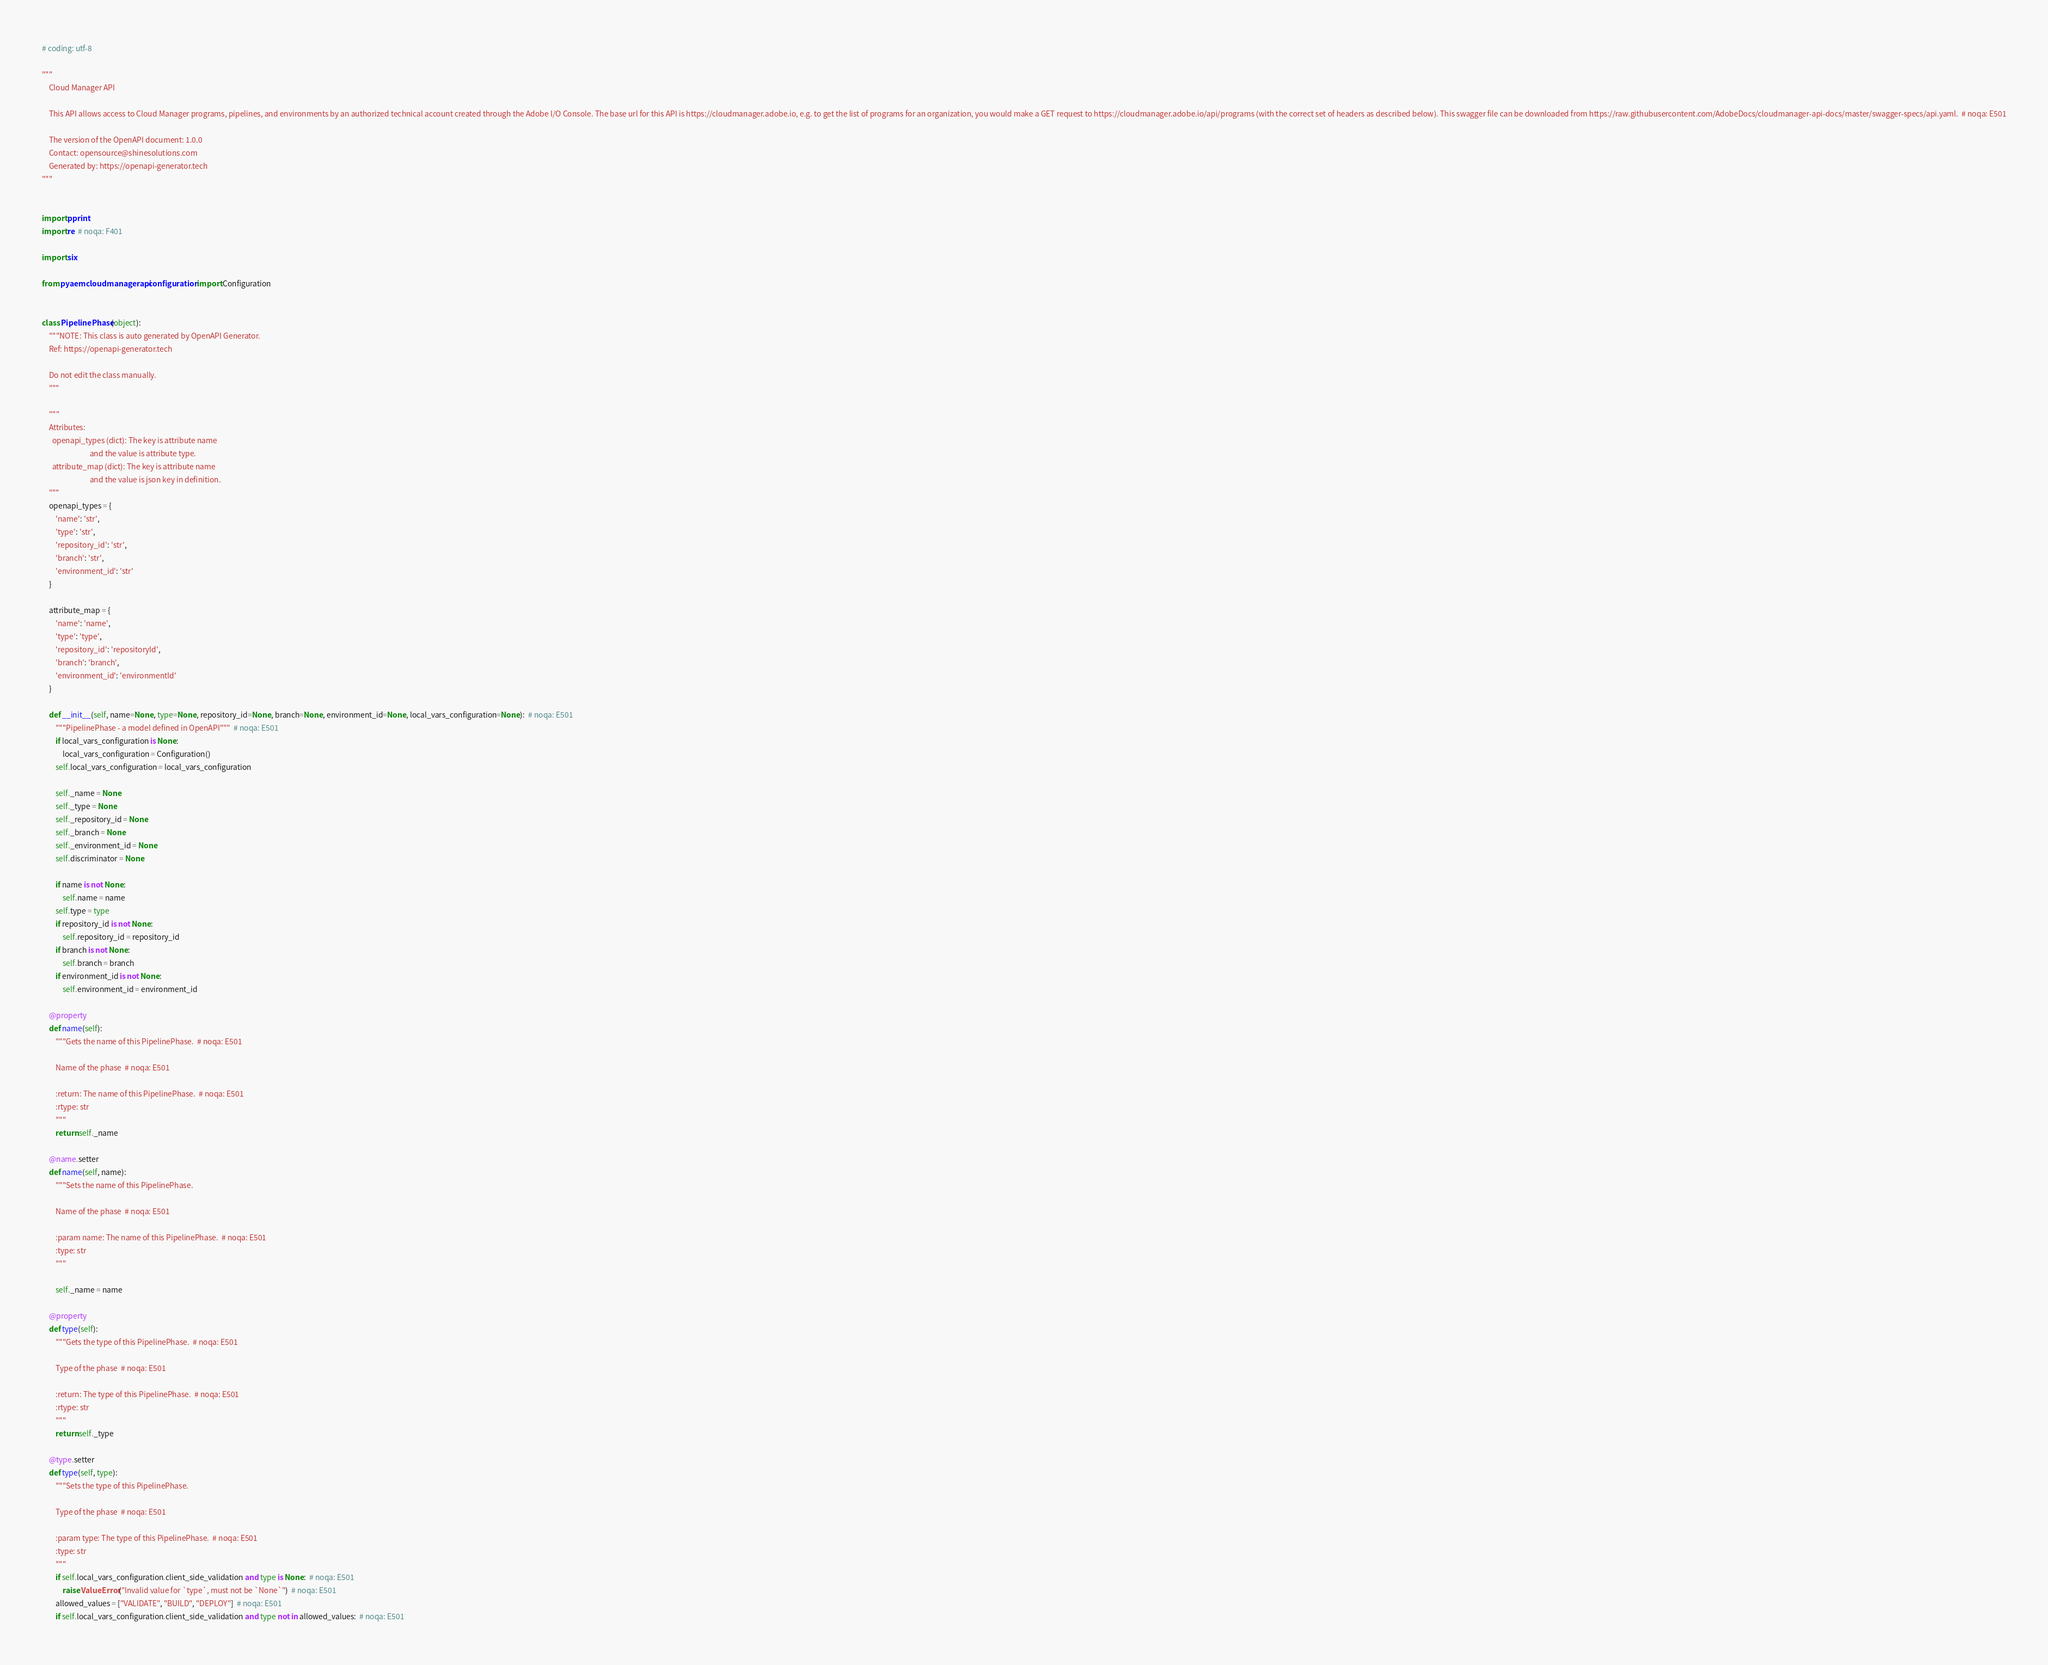Convert code to text. <code><loc_0><loc_0><loc_500><loc_500><_Python_># coding: utf-8

"""
    Cloud Manager API

    This API allows access to Cloud Manager programs, pipelines, and environments by an authorized technical account created through the Adobe I/O Console. The base url for this API is https://cloudmanager.adobe.io, e.g. to get the list of programs for an organization, you would make a GET request to https://cloudmanager.adobe.io/api/programs (with the correct set of headers as described below). This swagger file can be downloaded from https://raw.githubusercontent.com/AdobeDocs/cloudmanager-api-docs/master/swagger-specs/api.yaml.  # noqa: E501

    The version of the OpenAPI document: 1.0.0
    Contact: opensource@shinesolutions.com
    Generated by: https://openapi-generator.tech
"""


import pprint
import re  # noqa: F401

import six

from pyaemcloudmanagerapi.configuration import Configuration


class PipelinePhase(object):
    """NOTE: This class is auto generated by OpenAPI Generator.
    Ref: https://openapi-generator.tech

    Do not edit the class manually.
    """

    """
    Attributes:
      openapi_types (dict): The key is attribute name
                            and the value is attribute type.
      attribute_map (dict): The key is attribute name
                            and the value is json key in definition.
    """
    openapi_types = {
        'name': 'str',
        'type': 'str',
        'repository_id': 'str',
        'branch': 'str',
        'environment_id': 'str'
    }

    attribute_map = {
        'name': 'name',
        'type': 'type',
        'repository_id': 'repositoryId',
        'branch': 'branch',
        'environment_id': 'environmentId'
    }

    def __init__(self, name=None, type=None, repository_id=None, branch=None, environment_id=None, local_vars_configuration=None):  # noqa: E501
        """PipelinePhase - a model defined in OpenAPI"""  # noqa: E501
        if local_vars_configuration is None:
            local_vars_configuration = Configuration()
        self.local_vars_configuration = local_vars_configuration

        self._name = None
        self._type = None
        self._repository_id = None
        self._branch = None
        self._environment_id = None
        self.discriminator = None

        if name is not None:
            self.name = name
        self.type = type
        if repository_id is not None:
            self.repository_id = repository_id
        if branch is not None:
            self.branch = branch
        if environment_id is not None:
            self.environment_id = environment_id

    @property
    def name(self):
        """Gets the name of this PipelinePhase.  # noqa: E501

        Name of the phase  # noqa: E501

        :return: The name of this PipelinePhase.  # noqa: E501
        :rtype: str
        """
        return self._name

    @name.setter
    def name(self, name):
        """Sets the name of this PipelinePhase.

        Name of the phase  # noqa: E501

        :param name: The name of this PipelinePhase.  # noqa: E501
        :type: str
        """

        self._name = name

    @property
    def type(self):
        """Gets the type of this PipelinePhase.  # noqa: E501

        Type of the phase  # noqa: E501

        :return: The type of this PipelinePhase.  # noqa: E501
        :rtype: str
        """
        return self._type

    @type.setter
    def type(self, type):
        """Sets the type of this PipelinePhase.

        Type of the phase  # noqa: E501

        :param type: The type of this PipelinePhase.  # noqa: E501
        :type: str
        """
        if self.local_vars_configuration.client_side_validation and type is None:  # noqa: E501
            raise ValueError("Invalid value for `type`, must not be `None`")  # noqa: E501
        allowed_values = ["VALIDATE", "BUILD", "DEPLOY"]  # noqa: E501
        if self.local_vars_configuration.client_side_validation and type not in allowed_values:  # noqa: E501</code> 